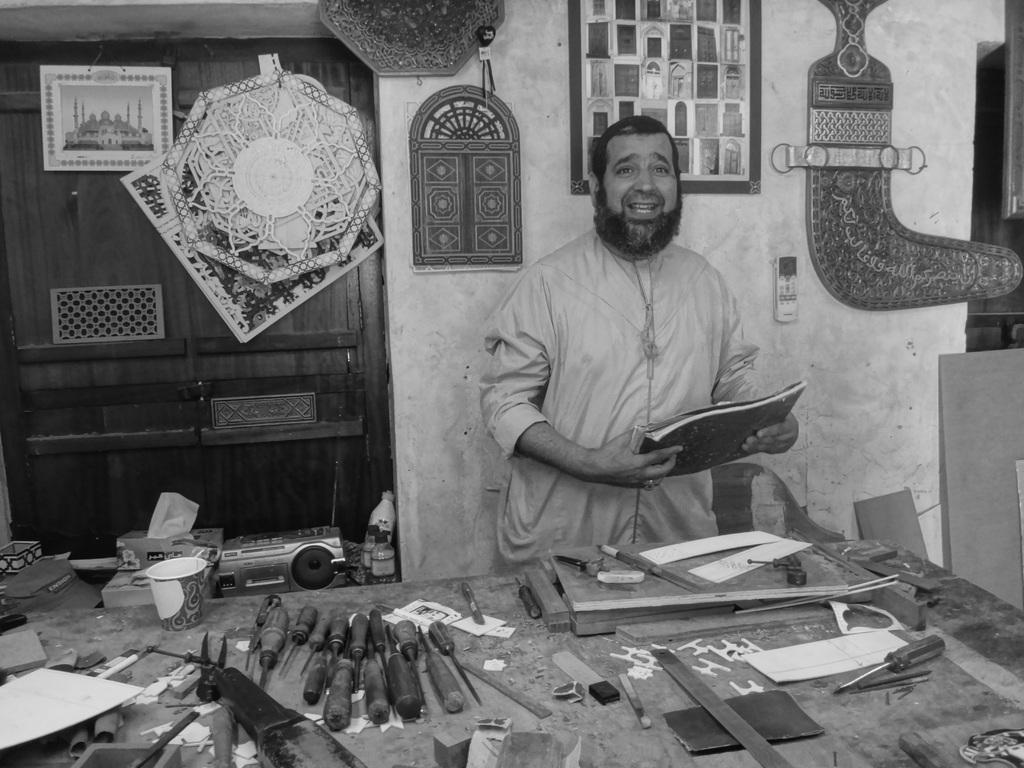How would you summarize this image in a sentence or two? This is the picture of a room. In this image there is a person standing behind the table and he is holding the book. There are tools and there is a cup, paper on the table. On the left side of the image there is a window and there are frames on window, at the bottom there is a device, cap on the wall. In the middle of the image there are frames on the wall. On the right side of the image there is a window. 